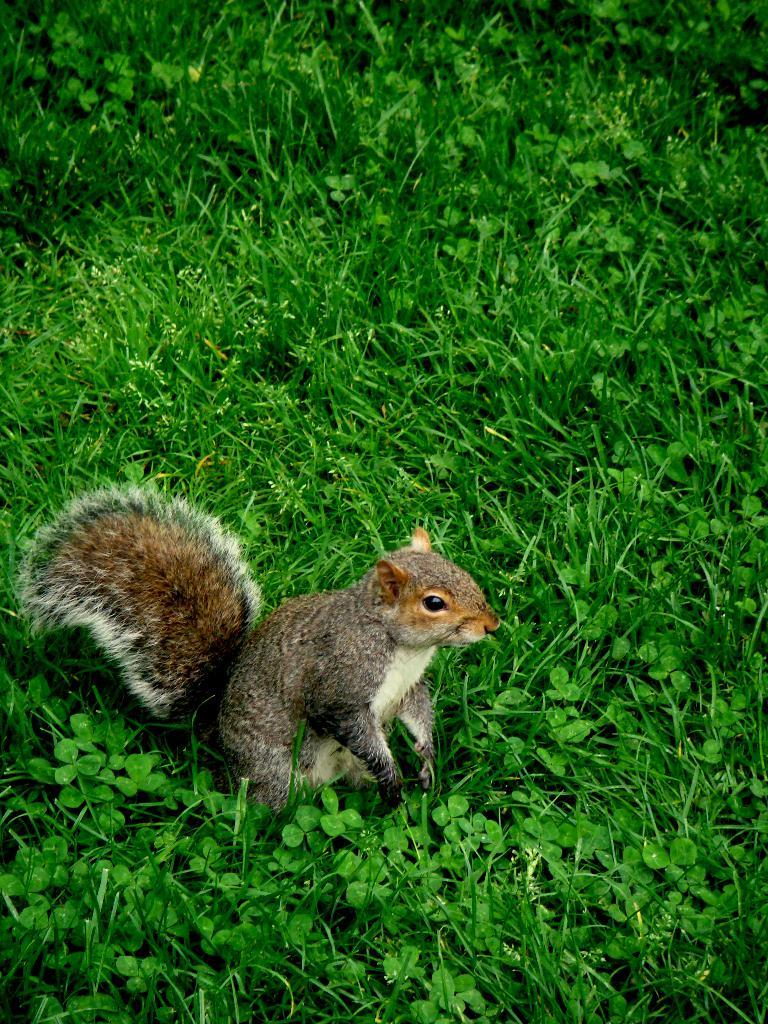What type of animal is in the picture? There is a squirrel in the picture. What is the ground made of in the picture? There is grass on the ground in the picture. What type of glass object is visible in the picture? There is no glass object present in the picture; it only features a squirrel and grass. What need does the squirrel have in the picture? The picture does not provide any information about the squirrel's needs or actions, so it cannot be determined from the image. 